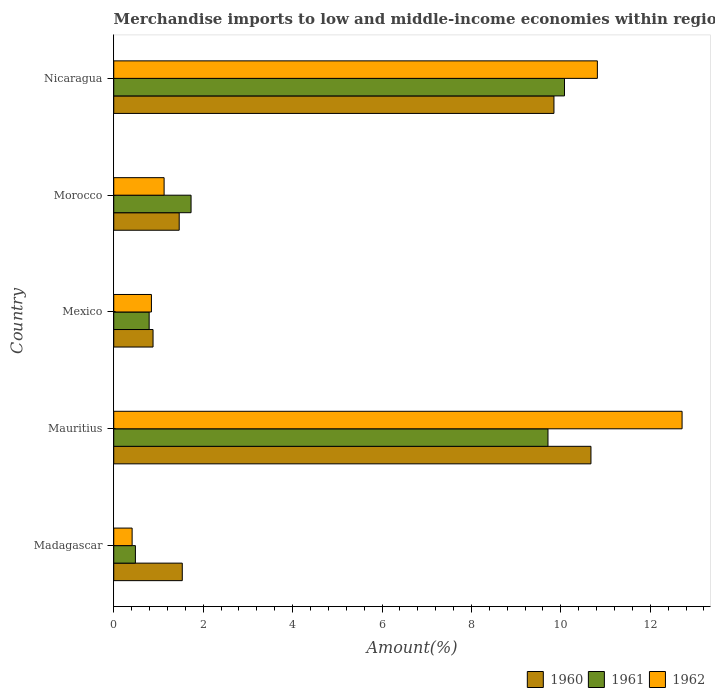How many different coloured bars are there?
Make the answer very short. 3. Are the number of bars per tick equal to the number of legend labels?
Your answer should be compact. Yes. How many bars are there on the 5th tick from the bottom?
Your answer should be very brief. 3. In how many cases, is the number of bars for a given country not equal to the number of legend labels?
Offer a very short reply. 0. What is the percentage of amount earned from merchandise imports in 1960 in Mauritius?
Your response must be concise. 10.67. Across all countries, what is the maximum percentage of amount earned from merchandise imports in 1961?
Keep it short and to the point. 10.08. Across all countries, what is the minimum percentage of amount earned from merchandise imports in 1962?
Your answer should be very brief. 0.41. In which country was the percentage of amount earned from merchandise imports in 1962 maximum?
Your answer should be compact. Mauritius. In which country was the percentage of amount earned from merchandise imports in 1961 minimum?
Offer a terse response. Madagascar. What is the total percentage of amount earned from merchandise imports in 1961 in the graph?
Ensure brevity in your answer.  22.8. What is the difference between the percentage of amount earned from merchandise imports in 1961 in Madagascar and that in Mexico?
Offer a very short reply. -0.31. What is the difference between the percentage of amount earned from merchandise imports in 1960 in Mauritius and the percentage of amount earned from merchandise imports in 1962 in Morocco?
Your answer should be compact. 9.55. What is the average percentage of amount earned from merchandise imports in 1962 per country?
Your response must be concise. 5.18. What is the difference between the percentage of amount earned from merchandise imports in 1960 and percentage of amount earned from merchandise imports in 1961 in Mauritius?
Provide a short and direct response. 0.96. What is the ratio of the percentage of amount earned from merchandise imports in 1962 in Madagascar to that in Mexico?
Your answer should be compact. 0.49. Is the percentage of amount earned from merchandise imports in 1961 in Mauritius less than that in Nicaragua?
Provide a short and direct response. Yes. What is the difference between the highest and the second highest percentage of amount earned from merchandise imports in 1962?
Make the answer very short. 1.89. What is the difference between the highest and the lowest percentage of amount earned from merchandise imports in 1960?
Ensure brevity in your answer.  9.79. In how many countries, is the percentage of amount earned from merchandise imports in 1960 greater than the average percentage of amount earned from merchandise imports in 1960 taken over all countries?
Your response must be concise. 2. Is the sum of the percentage of amount earned from merchandise imports in 1962 in Madagascar and Morocco greater than the maximum percentage of amount earned from merchandise imports in 1961 across all countries?
Keep it short and to the point. No. Is it the case that in every country, the sum of the percentage of amount earned from merchandise imports in 1962 and percentage of amount earned from merchandise imports in 1960 is greater than the percentage of amount earned from merchandise imports in 1961?
Give a very brief answer. Yes. Does the graph contain any zero values?
Ensure brevity in your answer.  No. Does the graph contain grids?
Offer a very short reply. No. How many legend labels are there?
Your response must be concise. 3. What is the title of the graph?
Keep it short and to the point. Merchandise imports to low and middle-income economies within region. What is the label or title of the X-axis?
Offer a terse response. Amount(%). What is the label or title of the Y-axis?
Your response must be concise. Country. What is the Amount(%) of 1960 in Madagascar?
Offer a very short reply. 1.53. What is the Amount(%) in 1961 in Madagascar?
Offer a terse response. 0.48. What is the Amount(%) of 1962 in Madagascar?
Your answer should be compact. 0.41. What is the Amount(%) of 1960 in Mauritius?
Keep it short and to the point. 10.67. What is the Amount(%) of 1961 in Mauritius?
Give a very brief answer. 9.71. What is the Amount(%) of 1962 in Mauritius?
Provide a short and direct response. 12.71. What is the Amount(%) in 1960 in Mexico?
Your response must be concise. 0.88. What is the Amount(%) in 1961 in Mexico?
Your answer should be very brief. 0.79. What is the Amount(%) of 1962 in Mexico?
Offer a very short reply. 0.84. What is the Amount(%) in 1960 in Morocco?
Ensure brevity in your answer.  1.46. What is the Amount(%) of 1961 in Morocco?
Your answer should be compact. 1.73. What is the Amount(%) in 1962 in Morocco?
Keep it short and to the point. 1.13. What is the Amount(%) in 1960 in Nicaragua?
Make the answer very short. 9.85. What is the Amount(%) in 1961 in Nicaragua?
Keep it short and to the point. 10.08. What is the Amount(%) of 1962 in Nicaragua?
Your answer should be very brief. 10.82. Across all countries, what is the maximum Amount(%) of 1960?
Your response must be concise. 10.67. Across all countries, what is the maximum Amount(%) in 1961?
Offer a terse response. 10.08. Across all countries, what is the maximum Amount(%) in 1962?
Your answer should be very brief. 12.71. Across all countries, what is the minimum Amount(%) of 1960?
Ensure brevity in your answer.  0.88. Across all countries, what is the minimum Amount(%) of 1961?
Provide a short and direct response. 0.48. Across all countries, what is the minimum Amount(%) of 1962?
Provide a succinct answer. 0.41. What is the total Amount(%) in 1960 in the graph?
Provide a succinct answer. 24.39. What is the total Amount(%) of 1961 in the graph?
Provide a short and direct response. 22.8. What is the total Amount(%) in 1962 in the graph?
Your response must be concise. 25.91. What is the difference between the Amount(%) in 1960 in Madagascar and that in Mauritius?
Provide a succinct answer. -9.14. What is the difference between the Amount(%) in 1961 in Madagascar and that in Mauritius?
Make the answer very short. -9.23. What is the difference between the Amount(%) of 1962 in Madagascar and that in Mauritius?
Offer a very short reply. -12.3. What is the difference between the Amount(%) of 1960 in Madagascar and that in Mexico?
Keep it short and to the point. 0.65. What is the difference between the Amount(%) of 1961 in Madagascar and that in Mexico?
Offer a very short reply. -0.31. What is the difference between the Amount(%) of 1962 in Madagascar and that in Mexico?
Offer a terse response. -0.43. What is the difference between the Amount(%) of 1960 in Madagascar and that in Morocco?
Offer a terse response. 0.07. What is the difference between the Amount(%) in 1961 in Madagascar and that in Morocco?
Your answer should be very brief. -1.24. What is the difference between the Amount(%) in 1962 in Madagascar and that in Morocco?
Your answer should be compact. -0.72. What is the difference between the Amount(%) of 1960 in Madagascar and that in Nicaragua?
Offer a terse response. -8.31. What is the difference between the Amount(%) of 1961 in Madagascar and that in Nicaragua?
Your response must be concise. -9.6. What is the difference between the Amount(%) in 1962 in Madagascar and that in Nicaragua?
Offer a terse response. -10.41. What is the difference between the Amount(%) in 1960 in Mauritius and that in Mexico?
Your response must be concise. 9.79. What is the difference between the Amount(%) of 1961 in Mauritius and that in Mexico?
Make the answer very short. 8.92. What is the difference between the Amount(%) of 1962 in Mauritius and that in Mexico?
Give a very brief answer. 11.87. What is the difference between the Amount(%) of 1960 in Mauritius and that in Morocco?
Your answer should be compact. 9.21. What is the difference between the Amount(%) of 1961 in Mauritius and that in Morocco?
Ensure brevity in your answer.  7.98. What is the difference between the Amount(%) in 1962 in Mauritius and that in Morocco?
Give a very brief answer. 11.58. What is the difference between the Amount(%) in 1960 in Mauritius and that in Nicaragua?
Offer a terse response. 0.83. What is the difference between the Amount(%) in 1961 in Mauritius and that in Nicaragua?
Offer a terse response. -0.37. What is the difference between the Amount(%) of 1962 in Mauritius and that in Nicaragua?
Keep it short and to the point. 1.89. What is the difference between the Amount(%) of 1960 in Mexico and that in Morocco?
Make the answer very short. -0.59. What is the difference between the Amount(%) of 1961 in Mexico and that in Morocco?
Keep it short and to the point. -0.94. What is the difference between the Amount(%) in 1962 in Mexico and that in Morocco?
Offer a terse response. -0.28. What is the difference between the Amount(%) of 1960 in Mexico and that in Nicaragua?
Keep it short and to the point. -8.97. What is the difference between the Amount(%) in 1961 in Mexico and that in Nicaragua?
Keep it short and to the point. -9.29. What is the difference between the Amount(%) of 1962 in Mexico and that in Nicaragua?
Offer a very short reply. -9.97. What is the difference between the Amount(%) of 1960 in Morocco and that in Nicaragua?
Your answer should be compact. -8.38. What is the difference between the Amount(%) in 1961 in Morocco and that in Nicaragua?
Offer a terse response. -8.35. What is the difference between the Amount(%) in 1962 in Morocco and that in Nicaragua?
Provide a succinct answer. -9.69. What is the difference between the Amount(%) in 1960 in Madagascar and the Amount(%) in 1961 in Mauritius?
Provide a succinct answer. -8.18. What is the difference between the Amount(%) in 1960 in Madagascar and the Amount(%) in 1962 in Mauritius?
Give a very brief answer. -11.18. What is the difference between the Amount(%) in 1961 in Madagascar and the Amount(%) in 1962 in Mauritius?
Offer a terse response. -12.23. What is the difference between the Amount(%) in 1960 in Madagascar and the Amount(%) in 1961 in Mexico?
Make the answer very short. 0.74. What is the difference between the Amount(%) of 1960 in Madagascar and the Amount(%) of 1962 in Mexico?
Provide a succinct answer. 0.69. What is the difference between the Amount(%) of 1961 in Madagascar and the Amount(%) of 1962 in Mexico?
Offer a very short reply. -0.36. What is the difference between the Amount(%) of 1960 in Madagascar and the Amount(%) of 1961 in Morocco?
Make the answer very short. -0.2. What is the difference between the Amount(%) of 1960 in Madagascar and the Amount(%) of 1962 in Morocco?
Ensure brevity in your answer.  0.41. What is the difference between the Amount(%) of 1961 in Madagascar and the Amount(%) of 1962 in Morocco?
Provide a short and direct response. -0.64. What is the difference between the Amount(%) in 1960 in Madagascar and the Amount(%) in 1961 in Nicaragua?
Keep it short and to the point. -8.55. What is the difference between the Amount(%) of 1960 in Madagascar and the Amount(%) of 1962 in Nicaragua?
Your answer should be very brief. -9.28. What is the difference between the Amount(%) of 1961 in Madagascar and the Amount(%) of 1962 in Nicaragua?
Provide a short and direct response. -10.33. What is the difference between the Amount(%) in 1960 in Mauritius and the Amount(%) in 1961 in Mexico?
Your answer should be compact. 9.88. What is the difference between the Amount(%) of 1960 in Mauritius and the Amount(%) of 1962 in Mexico?
Your answer should be compact. 9.83. What is the difference between the Amount(%) in 1961 in Mauritius and the Amount(%) in 1962 in Mexico?
Your answer should be compact. 8.87. What is the difference between the Amount(%) in 1960 in Mauritius and the Amount(%) in 1961 in Morocco?
Offer a terse response. 8.94. What is the difference between the Amount(%) of 1960 in Mauritius and the Amount(%) of 1962 in Morocco?
Ensure brevity in your answer.  9.55. What is the difference between the Amount(%) in 1961 in Mauritius and the Amount(%) in 1962 in Morocco?
Ensure brevity in your answer.  8.59. What is the difference between the Amount(%) in 1960 in Mauritius and the Amount(%) in 1961 in Nicaragua?
Ensure brevity in your answer.  0.59. What is the difference between the Amount(%) of 1960 in Mauritius and the Amount(%) of 1962 in Nicaragua?
Offer a terse response. -0.14. What is the difference between the Amount(%) of 1961 in Mauritius and the Amount(%) of 1962 in Nicaragua?
Your answer should be very brief. -1.1. What is the difference between the Amount(%) of 1960 in Mexico and the Amount(%) of 1961 in Morocco?
Your response must be concise. -0.85. What is the difference between the Amount(%) in 1960 in Mexico and the Amount(%) in 1962 in Morocco?
Your response must be concise. -0.25. What is the difference between the Amount(%) in 1961 in Mexico and the Amount(%) in 1962 in Morocco?
Keep it short and to the point. -0.33. What is the difference between the Amount(%) in 1960 in Mexico and the Amount(%) in 1961 in Nicaragua?
Give a very brief answer. -9.2. What is the difference between the Amount(%) in 1960 in Mexico and the Amount(%) in 1962 in Nicaragua?
Provide a short and direct response. -9.94. What is the difference between the Amount(%) in 1961 in Mexico and the Amount(%) in 1962 in Nicaragua?
Keep it short and to the point. -10.02. What is the difference between the Amount(%) in 1960 in Morocco and the Amount(%) in 1961 in Nicaragua?
Keep it short and to the point. -8.62. What is the difference between the Amount(%) in 1960 in Morocco and the Amount(%) in 1962 in Nicaragua?
Your answer should be compact. -9.35. What is the difference between the Amount(%) of 1961 in Morocco and the Amount(%) of 1962 in Nicaragua?
Offer a terse response. -9.09. What is the average Amount(%) of 1960 per country?
Offer a terse response. 4.88. What is the average Amount(%) in 1961 per country?
Offer a very short reply. 4.56. What is the average Amount(%) of 1962 per country?
Keep it short and to the point. 5.18. What is the difference between the Amount(%) in 1960 and Amount(%) in 1961 in Madagascar?
Offer a terse response. 1.05. What is the difference between the Amount(%) of 1960 and Amount(%) of 1962 in Madagascar?
Offer a very short reply. 1.12. What is the difference between the Amount(%) of 1961 and Amount(%) of 1962 in Madagascar?
Keep it short and to the point. 0.07. What is the difference between the Amount(%) of 1960 and Amount(%) of 1961 in Mauritius?
Your answer should be compact. 0.96. What is the difference between the Amount(%) in 1960 and Amount(%) in 1962 in Mauritius?
Your response must be concise. -2.04. What is the difference between the Amount(%) of 1961 and Amount(%) of 1962 in Mauritius?
Your answer should be very brief. -3. What is the difference between the Amount(%) of 1960 and Amount(%) of 1961 in Mexico?
Your answer should be very brief. 0.09. What is the difference between the Amount(%) in 1960 and Amount(%) in 1962 in Mexico?
Provide a succinct answer. 0.04. What is the difference between the Amount(%) in 1961 and Amount(%) in 1962 in Mexico?
Your response must be concise. -0.05. What is the difference between the Amount(%) in 1960 and Amount(%) in 1961 in Morocco?
Keep it short and to the point. -0.27. What is the difference between the Amount(%) of 1960 and Amount(%) of 1962 in Morocco?
Offer a very short reply. 0.34. What is the difference between the Amount(%) of 1961 and Amount(%) of 1962 in Morocco?
Ensure brevity in your answer.  0.6. What is the difference between the Amount(%) in 1960 and Amount(%) in 1961 in Nicaragua?
Your response must be concise. -0.24. What is the difference between the Amount(%) in 1960 and Amount(%) in 1962 in Nicaragua?
Give a very brief answer. -0.97. What is the difference between the Amount(%) in 1961 and Amount(%) in 1962 in Nicaragua?
Your answer should be very brief. -0.74. What is the ratio of the Amount(%) of 1960 in Madagascar to that in Mauritius?
Keep it short and to the point. 0.14. What is the ratio of the Amount(%) of 1961 in Madagascar to that in Mauritius?
Provide a succinct answer. 0.05. What is the ratio of the Amount(%) of 1962 in Madagascar to that in Mauritius?
Your response must be concise. 0.03. What is the ratio of the Amount(%) in 1960 in Madagascar to that in Mexico?
Provide a short and direct response. 1.74. What is the ratio of the Amount(%) in 1961 in Madagascar to that in Mexico?
Your response must be concise. 0.61. What is the ratio of the Amount(%) in 1962 in Madagascar to that in Mexico?
Offer a very short reply. 0.49. What is the ratio of the Amount(%) in 1960 in Madagascar to that in Morocco?
Your answer should be very brief. 1.05. What is the ratio of the Amount(%) in 1961 in Madagascar to that in Morocco?
Your response must be concise. 0.28. What is the ratio of the Amount(%) of 1962 in Madagascar to that in Morocco?
Your response must be concise. 0.36. What is the ratio of the Amount(%) in 1960 in Madagascar to that in Nicaragua?
Make the answer very short. 0.16. What is the ratio of the Amount(%) of 1961 in Madagascar to that in Nicaragua?
Make the answer very short. 0.05. What is the ratio of the Amount(%) in 1962 in Madagascar to that in Nicaragua?
Provide a succinct answer. 0.04. What is the ratio of the Amount(%) of 1960 in Mauritius to that in Mexico?
Keep it short and to the point. 12.14. What is the ratio of the Amount(%) of 1961 in Mauritius to that in Mexico?
Your response must be concise. 12.26. What is the ratio of the Amount(%) in 1962 in Mauritius to that in Mexico?
Your answer should be compact. 15.08. What is the ratio of the Amount(%) of 1960 in Mauritius to that in Morocco?
Ensure brevity in your answer.  7.29. What is the ratio of the Amount(%) of 1961 in Mauritius to that in Morocco?
Offer a very short reply. 5.62. What is the ratio of the Amount(%) of 1962 in Mauritius to that in Morocco?
Your answer should be compact. 11.28. What is the ratio of the Amount(%) in 1960 in Mauritius to that in Nicaragua?
Make the answer very short. 1.08. What is the ratio of the Amount(%) in 1961 in Mauritius to that in Nicaragua?
Ensure brevity in your answer.  0.96. What is the ratio of the Amount(%) of 1962 in Mauritius to that in Nicaragua?
Your answer should be compact. 1.18. What is the ratio of the Amount(%) in 1960 in Mexico to that in Morocco?
Make the answer very short. 0.6. What is the ratio of the Amount(%) in 1961 in Mexico to that in Morocco?
Your response must be concise. 0.46. What is the ratio of the Amount(%) in 1962 in Mexico to that in Morocco?
Offer a very short reply. 0.75. What is the ratio of the Amount(%) in 1960 in Mexico to that in Nicaragua?
Offer a terse response. 0.09. What is the ratio of the Amount(%) of 1961 in Mexico to that in Nicaragua?
Your answer should be compact. 0.08. What is the ratio of the Amount(%) of 1962 in Mexico to that in Nicaragua?
Offer a very short reply. 0.08. What is the ratio of the Amount(%) in 1960 in Morocco to that in Nicaragua?
Offer a very short reply. 0.15. What is the ratio of the Amount(%) in 1961 in Morocco to that in Nicaragua?
Offer a very short reply. 0.17. What is the ratio of the Amount(%) in 1962 in Morocco to that in Nicaragua?
Your response must be concise. 0.1. What is the difference between the highest and the second highest Amount(%) of 1960?
Your answer should be very brief. 0.83. What is the difference between the highest and the second highest Amount(%) in 1961?
Your response must be concise. 0.37. What is the difference between the highest and the second highest Amount(%) in 1962?
Your answer should be compact. 1.89. What is the difference between the highest and the lowest Amount(%) of 1960?
Ensure brevity in your answer.  9.79. What is the difference between the highest and the lowest Amount(%) in 1961?
Your response must be concise. 9.6. What is the difference between the highest and the lowest Amount(%) of 1962?
Your answer should be compact. 12.3. 